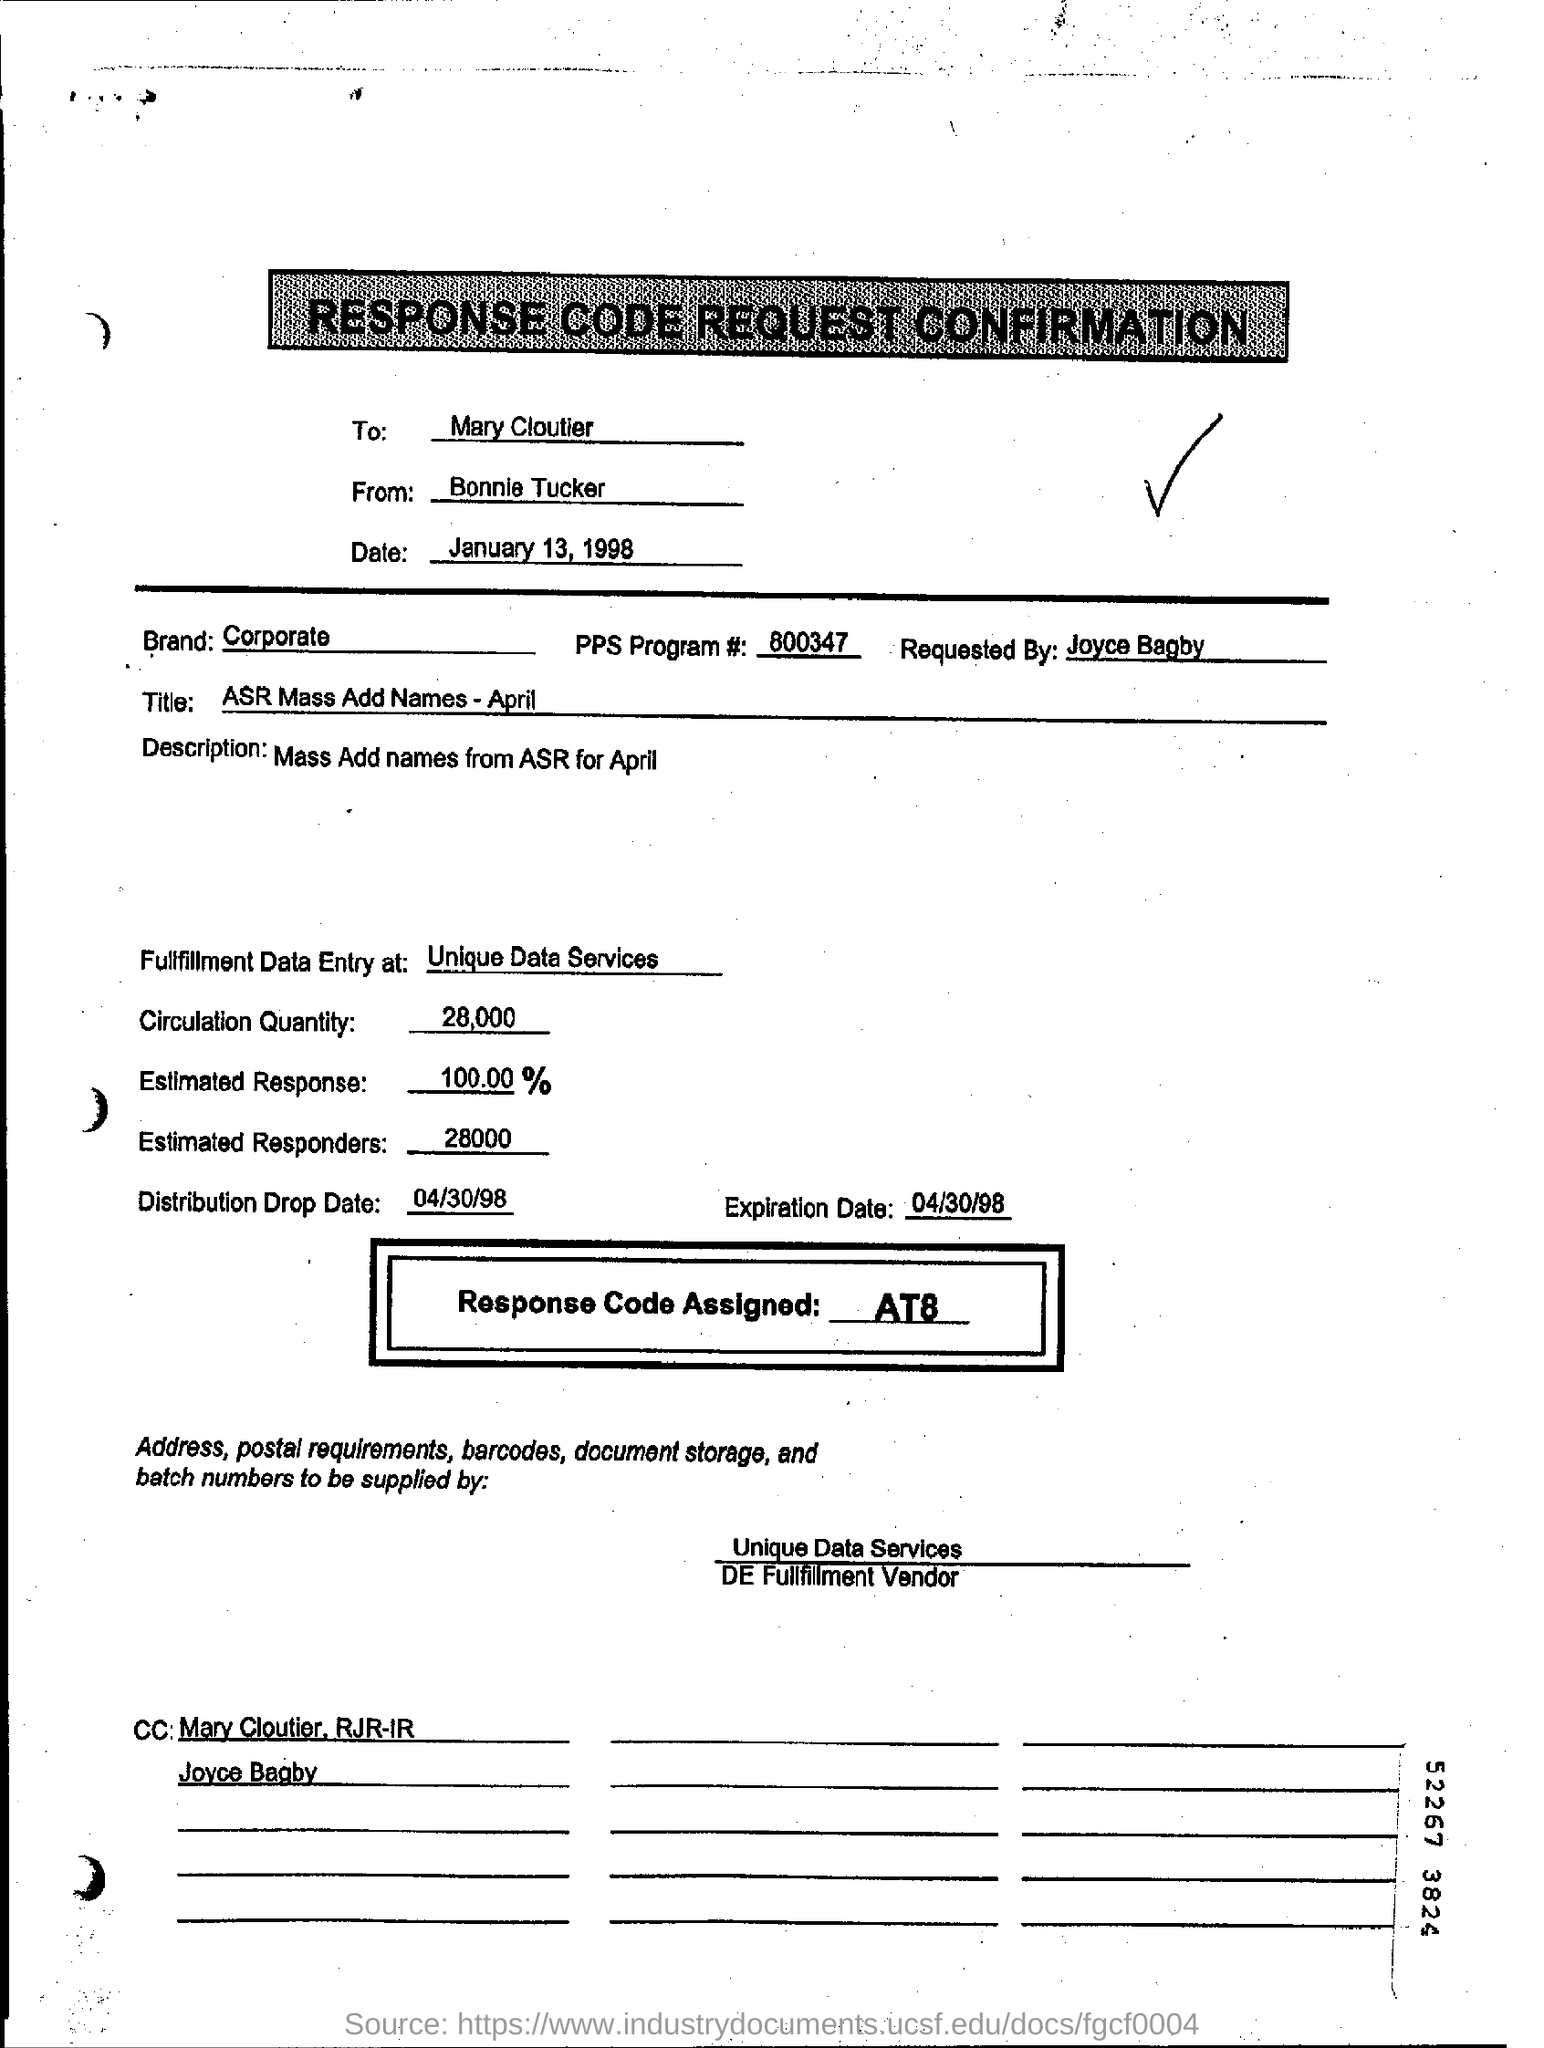Draw attention to some important aspects in this diagram. The expiration date is April 30, 1998. The estimated number of responders is 28,000. There are 800347 PPS programs. The distribution drop date is a specific date on which a distribution of goods or materials is scheduled to take place. In the case of the example provided, the distribution drop date is April 30, 1998. On January 13, 1998, a request for confirmation was made with a response code. The request was dated at that time. 